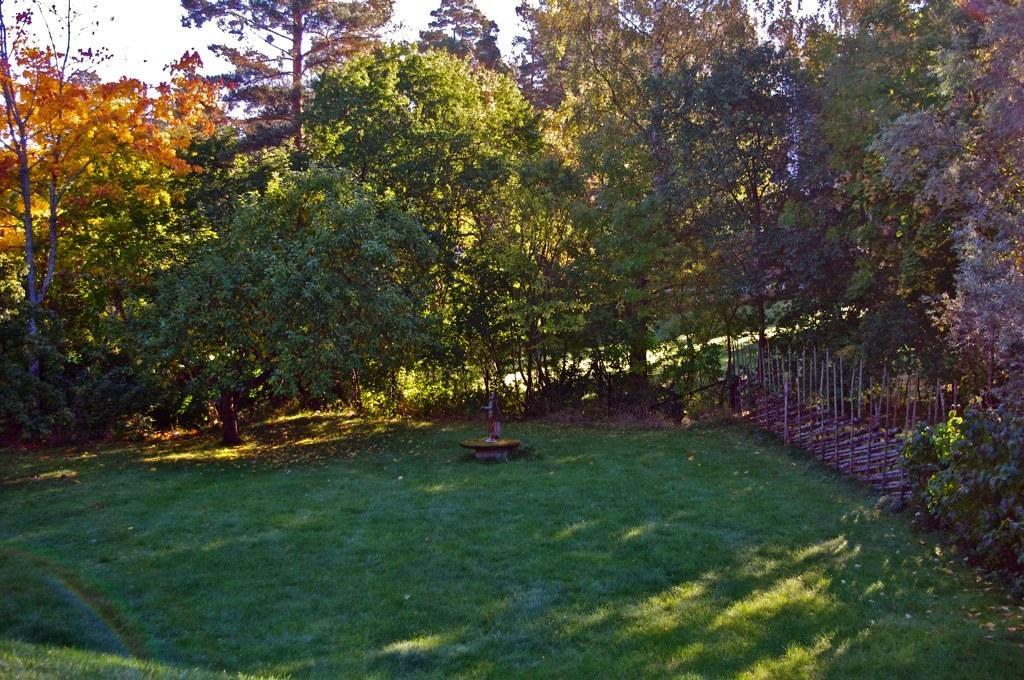What type of vegetation can be seen in the image? There is grass in the image. What is the other prominent feature in the image? There is a statue in the image. Are there any other plants visible in the image? Yes, there are trees in the image. What can be seen in the background of the image? The sky is visible in the background of the image. What type of hobbies can be seen being practiced by the statue in the image? The image does not depict any hobbies being practiced by the statue, as it is a static object. How many dimes are visible on the grass in the image? There are no dimes visible on the grass in the image. 